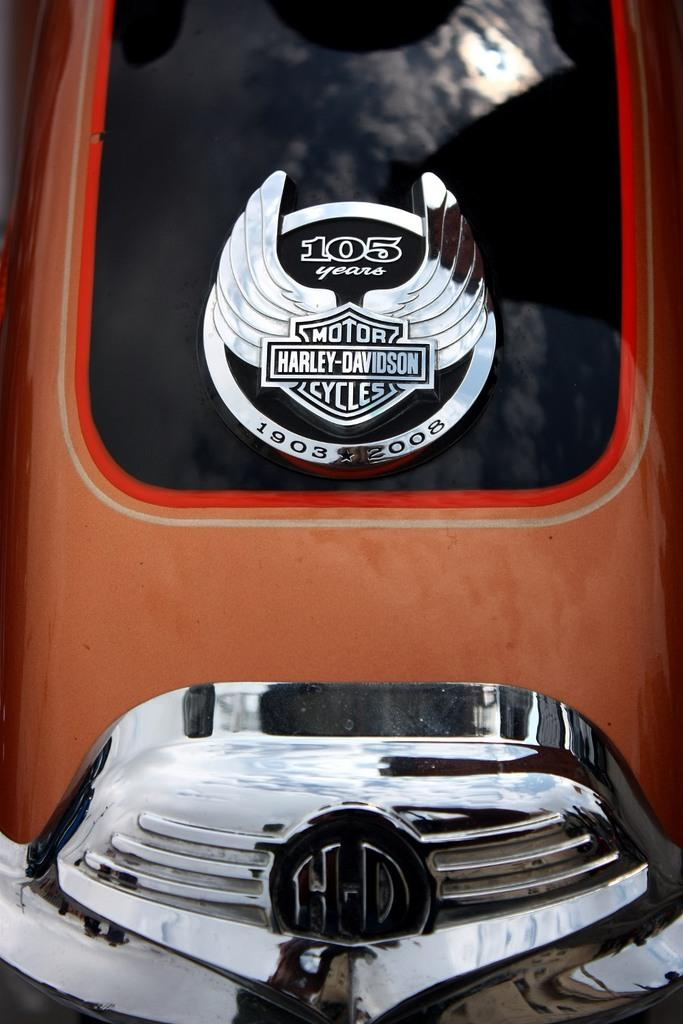What type of object is the main subject in the image? There is a vehicle in the image. Can you describe any specific features of the vehicle? There is a logo visible on the vehicle. What material is present on the vehicle? There is glass present on the vehicle. What can be seen on the glass surface? There is a reflection visible on the glass. How many clams are attached to the vehicle's logo in the image? There are no clams present in the image, and the vehicle's logo does not feature any clams. 